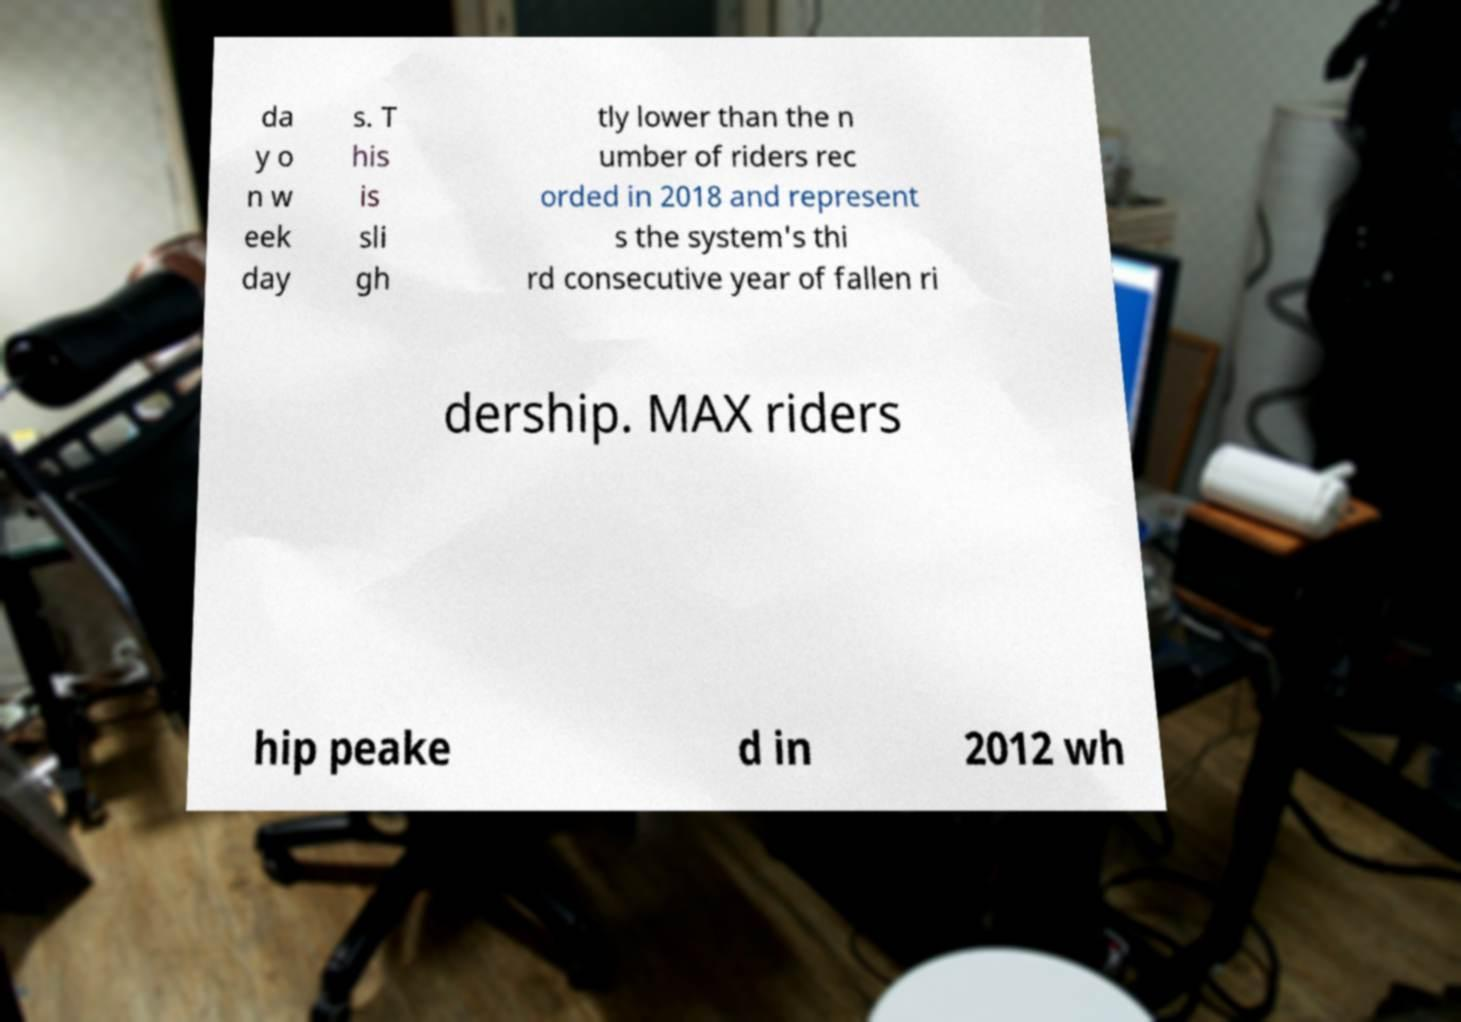Could you extract and type out the text from this image? da y o n w eek day s. T his is sli gh tly lower than the n umber of riders rec orded in 2018 and represent s the system's thi rd consecutive year of fallen ri dership. MAX riders hip peake d in 2012 wh 